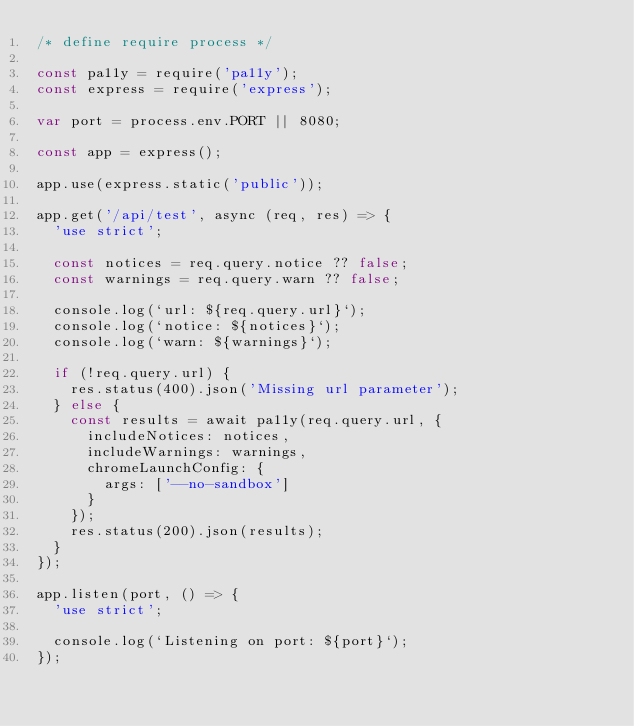<code> <loc_0><loc_0><loc_500><loc_500><_JavaScript_>/* define require process */

const pa11y = require('pa11y');
const express = require('express');

var port = process.env.PORT || 8080;

const app = express();

app.use(express.static('public'));

app.get('/api/test', async (req, res) => {
  'use strict';

  const notices = req.query.notice ?? false;
  const warnings = req.query.warn ?? false;

  console.log(`url: ${req.query.url}`);
  console.log(`notice: ${notices}`);
  console.log(`warn: ${warnings}`);

  if (!req.query.url) {
    res.status(400).json('Missing url parameter');
  } else {
    const results = await pa11y(req.query.url, {
      includeNotices: notices,
      includeWarnings: warnings,
      chromeLaunchConfig: {
        args: ['--no-sandbox']
      }
    });
    res.status(200).json(results);
  }
});

app.listen(port, () => {
  'use strict';

  console.log(`Listening on port: ${port}`);
});
</code> 